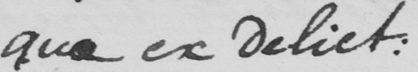Transcribe the text shown in this historical manuscript line. qua ex delict : 